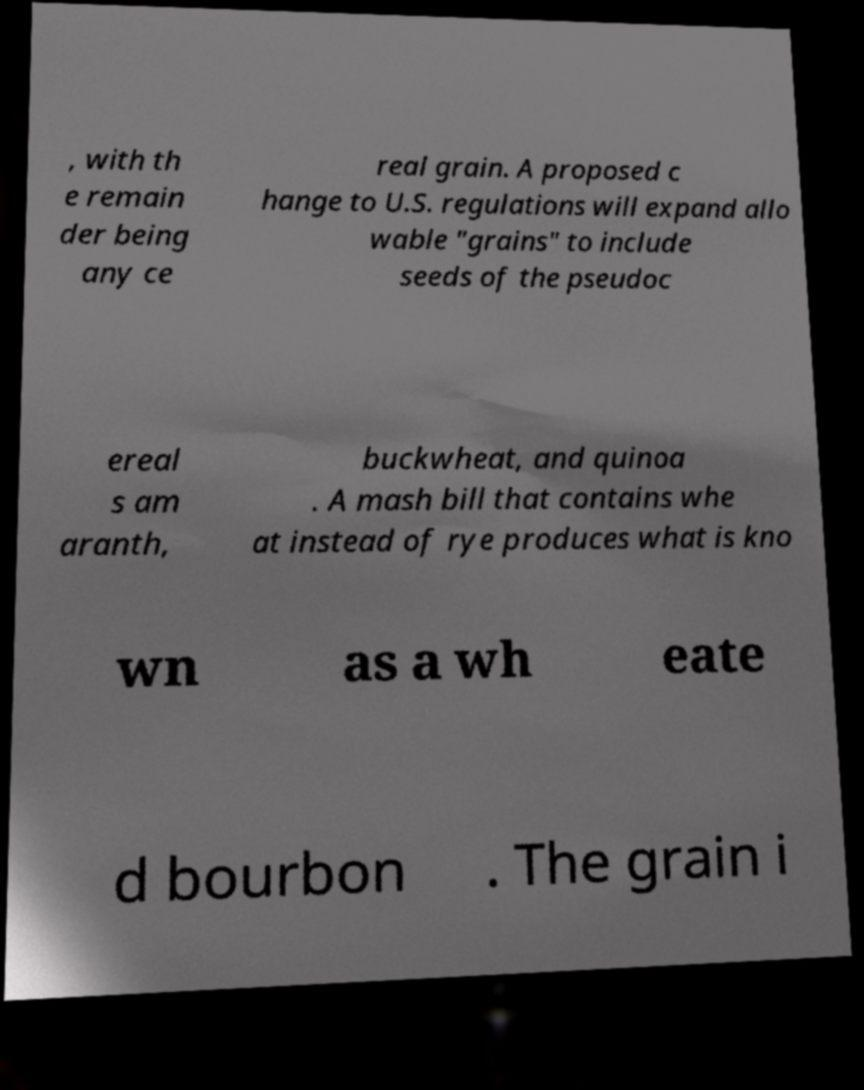Can you accurately transcribe the text from the provided image for me? , with th e remain der being any ce real grain. A proposed c hange to U.S. regulations will expand allo wable "grains" to include seeds of the pseudoc ereal s am aranth, buckwheat, and quinoa . A mash bill that contains whe at instead of rye produces what is kno wn as a wh eate d bourbon . The grain i 